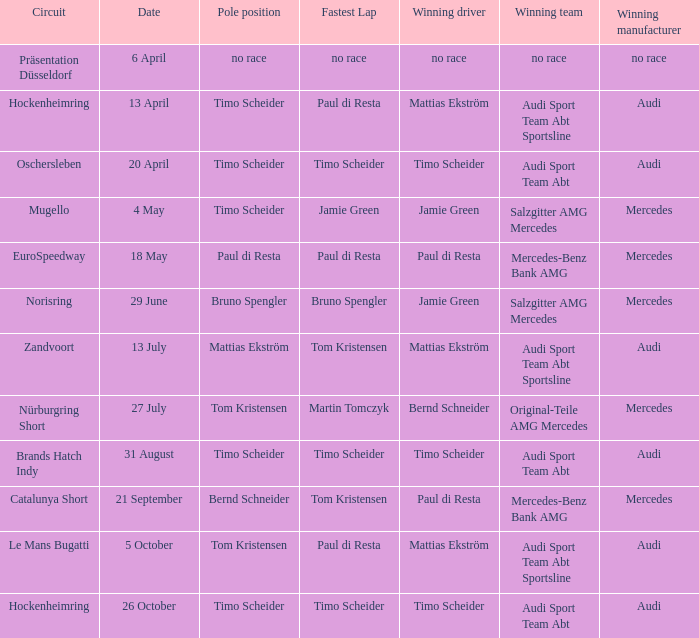What is the victorious team of the race on 31 august with audi as the triumphant manufacturer and timo scheider as the successful driver? Audi Sport Team Abt. 